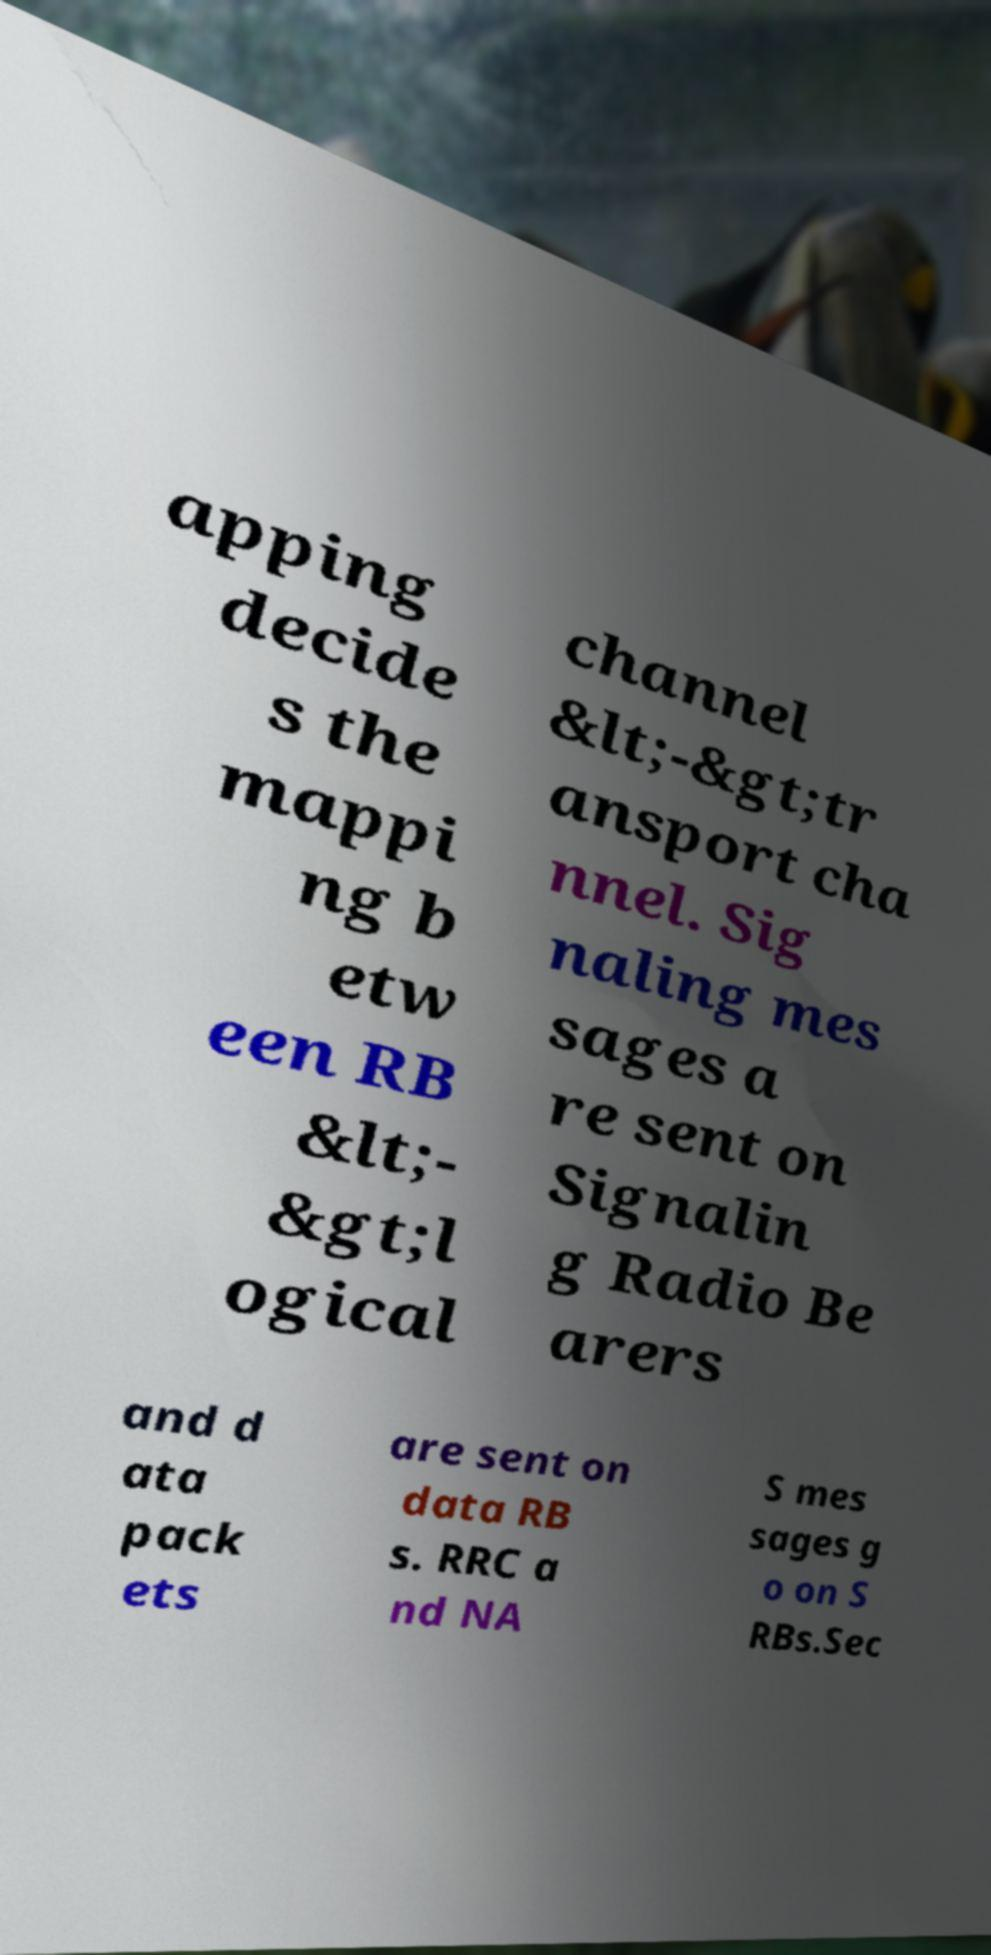Please read and relay the text visible in this image. What does it say? apping decide s the mappi ng b etw een RB &lt;- &gt;l ogical channel &lt;-&gt;tr ansport cha nnel. Sig naling mes sages a re sent on Signalin g Radio Be arers and d ata pack ets are sent on data RB s. RRC a nd NA S mes sages g o on S RBs.Sec 